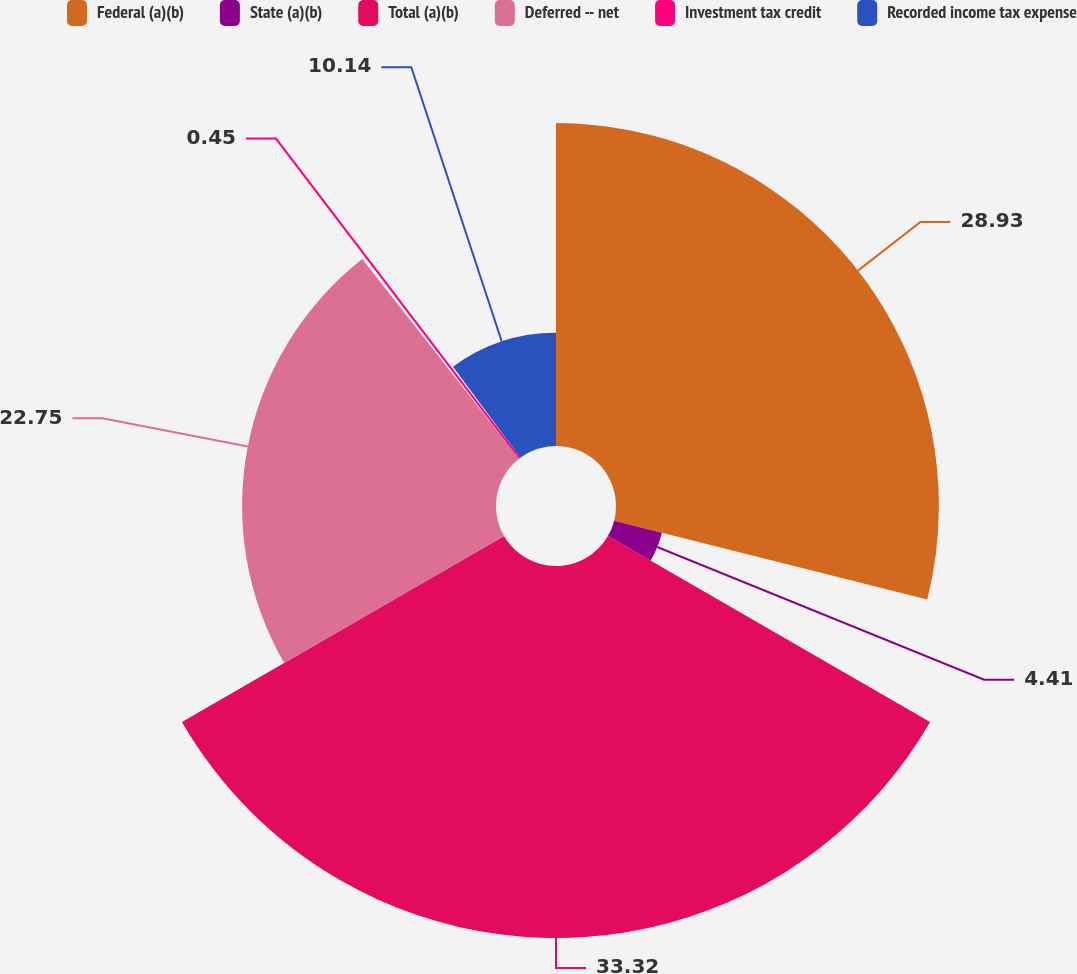<chart> <loc_0><loc_0><loc_500><loc_500><pie_chart><fcel>Federal (a)(b)<fcel>State (a)(b)<fcel>Total (a)(b)<fcel>Deferred -- net<fcel>Investment tax credit<fcel>Recorded income tax expense<nl><fcel>28.93%<fcel>4.41%<fcel>33.33%<fcel>22.75%<fcel>0.45%<fcel>10.14%<nl></chart> 